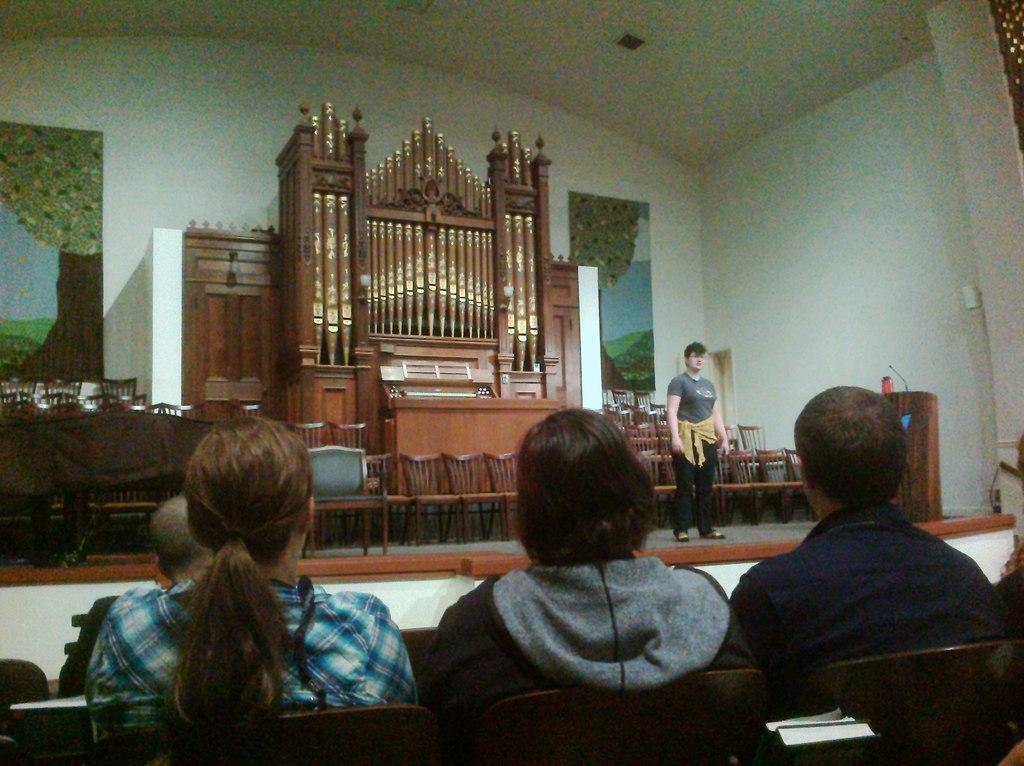Could you give a brief overview of what you see in this image? In this picture I can see few people in front, who are sitting on chairs and in the background I can see the platform on which I see a person who is standing and behind the person I can see number of chairs and few brown color things and I can see the wall on which there are pictures. On the right side of this picture I can see a podium. 